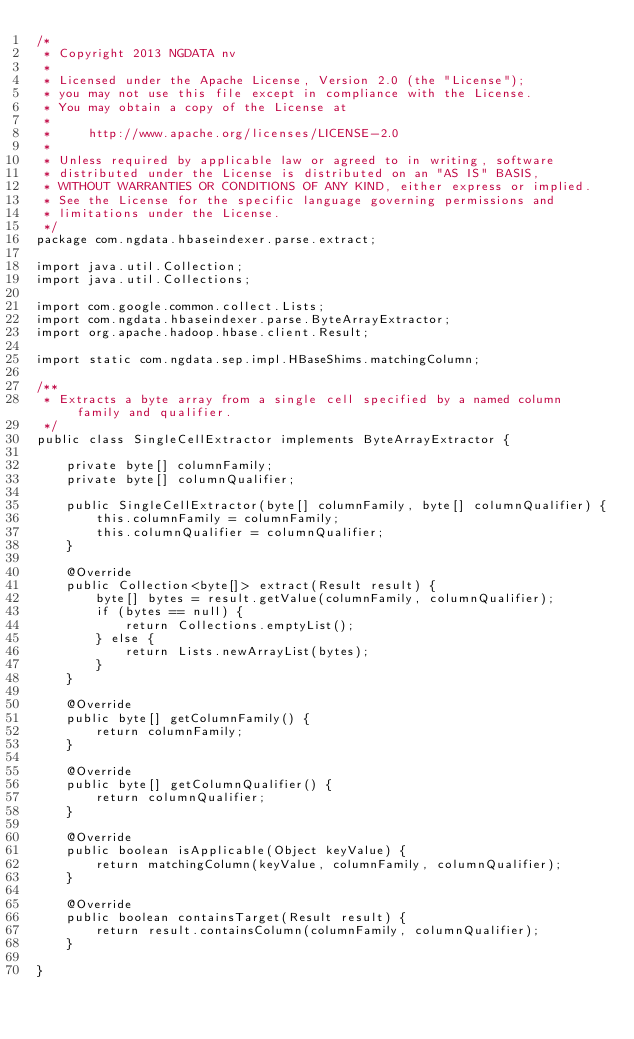Convert code to text. <code><loc_0><loc_0><loc_500><loc_500><_Java_>/*
 * Copyright 2013 NGDATA nv
 *
 * Licensed under the Apache License, Version 2.0 (the "License");
 * you may not use this file except in compliance with the License.
 * You may obtain a copy of the License at
 *
 *     http://www.apache.org/licenses/LICENSE-2.0
 *
 * Unless required by applicable law or agreed to in writing, software
 * distributed under the License is distributed on an "AS IS" BASIS,
 * WITHOUT WARRANTIES OR CONDITIONS OF ANY KIND, either express or implied.
 * See the License for the specific language governing permissions and
 * limitations under the License.
 */
package com.ngdata.hbaseindexer.parse.extract;

import java.util.Collection;
import java.util.Collections;

import com.google.common.collect.Lists;
import com.ngdata.hbaseindexer.parse.ByteArrayExtractor;
import org.apache.hadoop.hbase.client.Result;

import static com.ngdata.sep.impl.HBaseShims.matchingColumn;

/**
 * Extracts a byte array from a single cell specified by a named column family and qualifier.
 */
public class SingleCellExtractor implements ByteArrayExtractor {

    private byte[] columnFamily;
    private byte[] columnQualifier;

    public SingleCellExtractor(byte[] columnFamily, byte[] columnQualifier) {
        this.columnFamily = columnFamily;
        this.columnQualifier = columnQualifier;
    }

    @Override
    public Collection<byte[]> extract(Result result) {
        byte[] bytes = result.getValue(columnFamily, columnQualifier);
        if (bytes == null) {
            return Collections.emptyList();
        } else {
            return Lists.newArrayList(bytes);
        }
    }
    
    @Override
    public byte[] getColumnFamily() {
        return columnFamily;
    }
    
    @Override
    public byte[] getColumnQualifier() {
        return columnQualifier;
    }
    
    @Override
    public boolean isApplicable(Object keyValue) {
        return matchingColumn(keyValue, columnFamily, columnQualifier);
    }

    @Override
    public boolean containsTarget(Result result) {
        return result.containsColumn(columnFamily, columnQualifier);
    }

}
</code> 